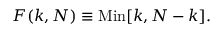<formula> <loc_0><loc_0><loc_500><loc_500>F ( k , N ) \equiv M i n [ k , N - k ] .</formula> 